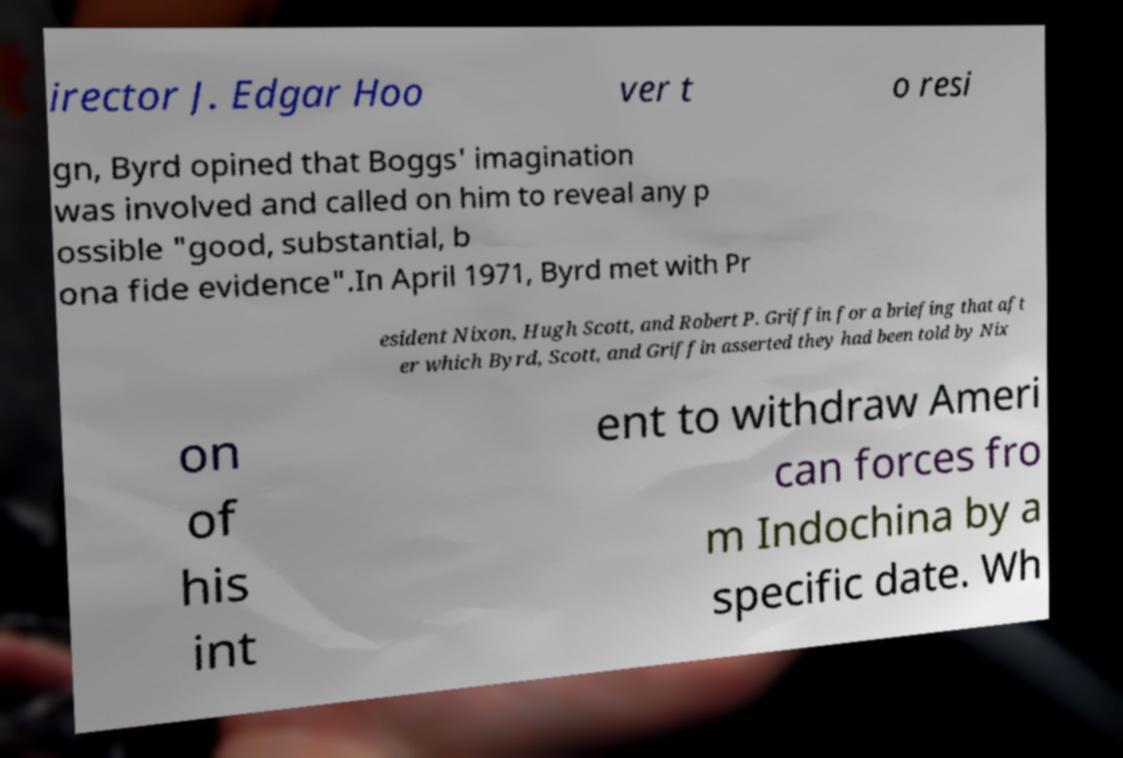For documentation purposes, I need the text within this image transcribed. Could you provide that? irector J. Edgar Hoo ver t o resi gn, Byrd opined that Boggs' imagination was involved and called on him to reveal any p ossible "good, substantial, b ona fide evidence".In April 1971, Byrd met with Pr esident Nixon, Hugh Scott, and Robert P. Griffin for a briefing that aft er which Byrd, Scott, and Griffin asserted they had been told by Nix on of his int ent to withdraw Ameri can forces fro m Indochina by a specific date. Wh 